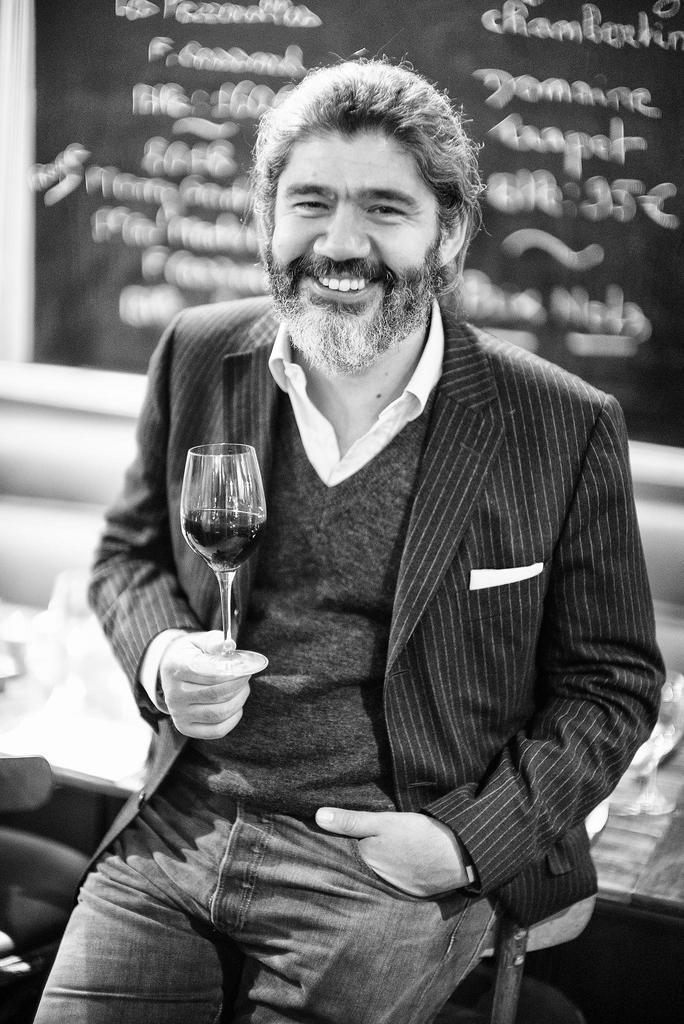Who is present in the image? There is a man in the image. What is the man doing in the image? The man is leaning on a bench. What is the man holding in his right hand? The man is holding a wine glass in his right hand. How many pizzas are on the bench next to the man? There are no pizzas present in the image; only the man and a wine glass are visible. 